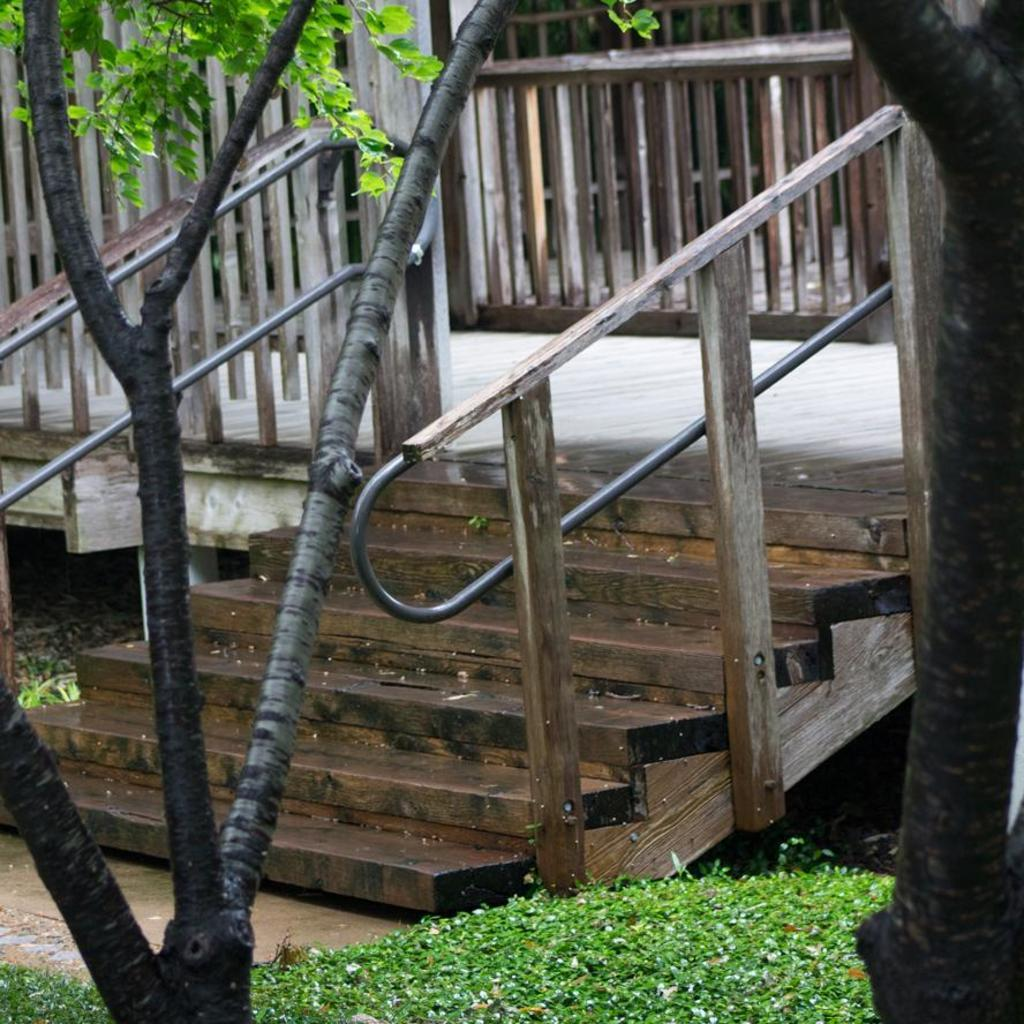What type of structure is visible in the image? There are stairs of a building in the image. What can be seen in front of the stairs? There are trees and plants in front of the stairs. How many legs does the spark have in the image? There is no spark present in the image, so it is not possible to determine how many legs it might have. 